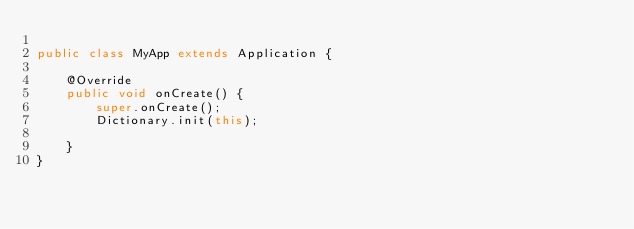Convert code to text. <code><loc_0><loc_0><loc_500><loc_500><_Java_>
public class MyApp extends Application {

    @Override
    public void onCreate() {
        super.onCreate();
        Dictionary.init(this);

    }
}
</code> 